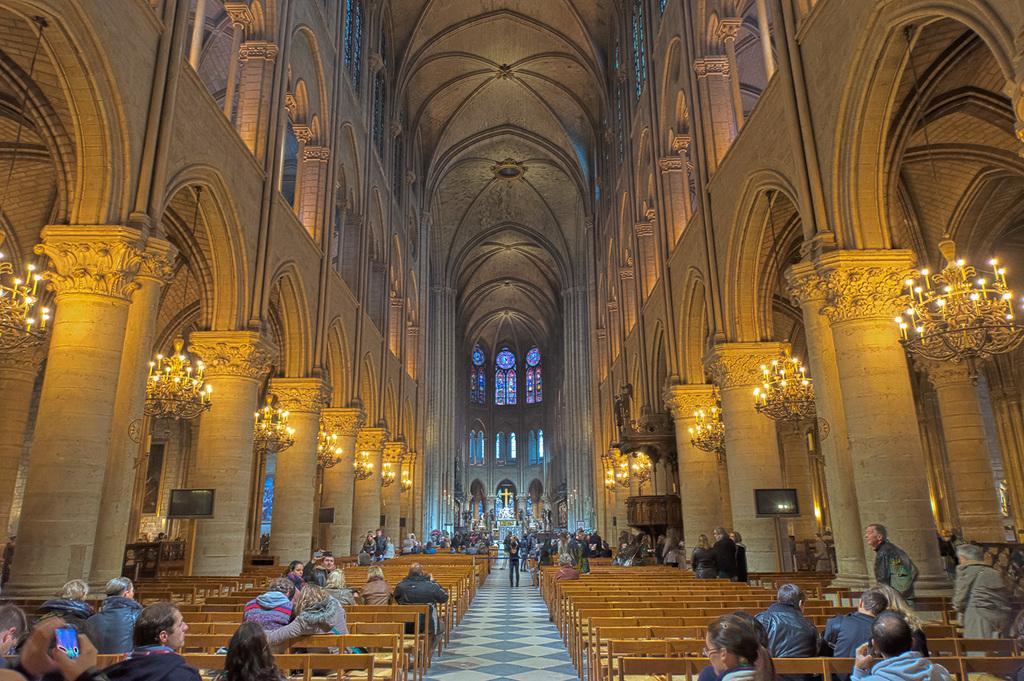Describe this image in one or two sentences. It is an inside view of the church. There are so many pillars, chandeliers, walls, television, benches. At the bottom, we can see a group of people. Few are sitting and standing. Here a person is holding a mobile. Background we can see holy cross, glass windows. Top of the image, there is a roof. 